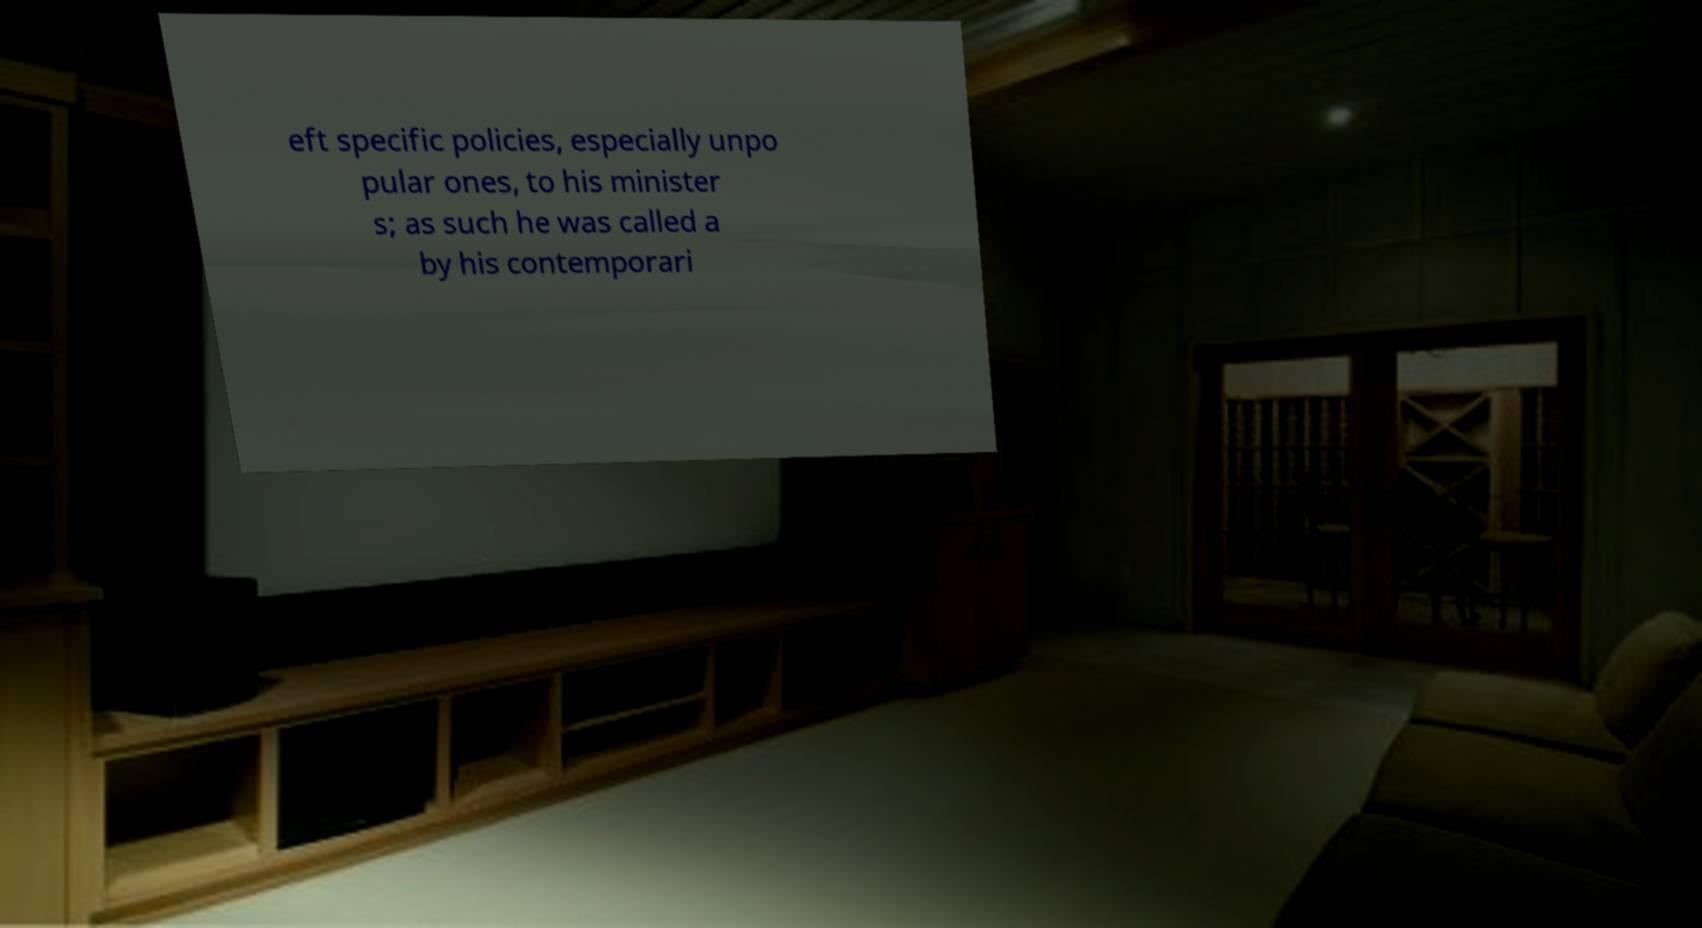Can you read and provide the text displayed in the image?This photo seems to have some interesting text. Can you extract and type it out for me? eft specific policies, especially unpo pular ones, to his minister s; as such he was called a by his contemporari 